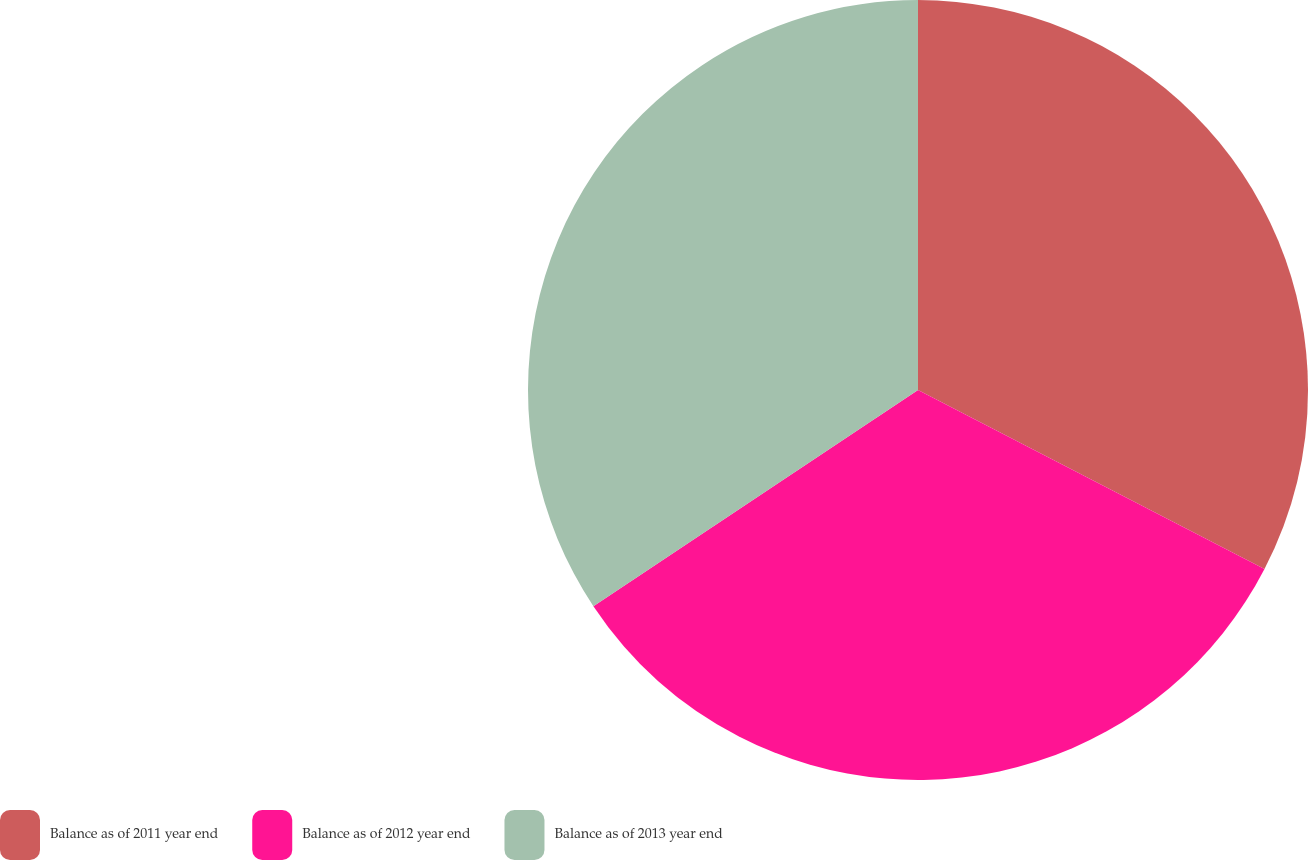Convert chart. <chart><loc_0><loc_0><loc_500><loc_500><pie_chart><fcel>Balance as of 2011 year end<fcel>Balance as of 2012 year end<fcel>Balance as of 2013 year end<nl><fcel>32.59%<fcel>33.06%<fcel>34.35%<nl></chart> 